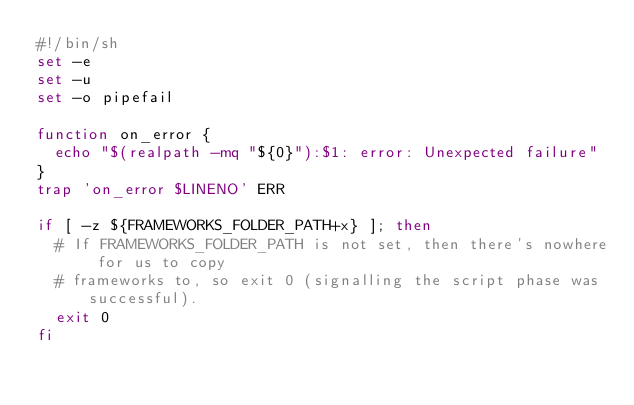Convert code to text. <code><loc_0><loc_0><loc_500><loc_500><_Bash_>#!/bin/sh
set -e
set -u
set -o pipefail

function on_error {
  echo "$(realpath -mq "${0}"):$1: error: Unexpected failure"
}
trap 'on_error $LINENO' ERR

if [ -z ${FRAMEWORKS_FOLDER_PATH+x} ]; then
  # If FRAMEWORKS_FOLDER_PATH is not set, then there's nowhere for us to copy
  # frameworks to, so exit 0 (signalling the script phase was successful).
  exit 0
fi
</code> 